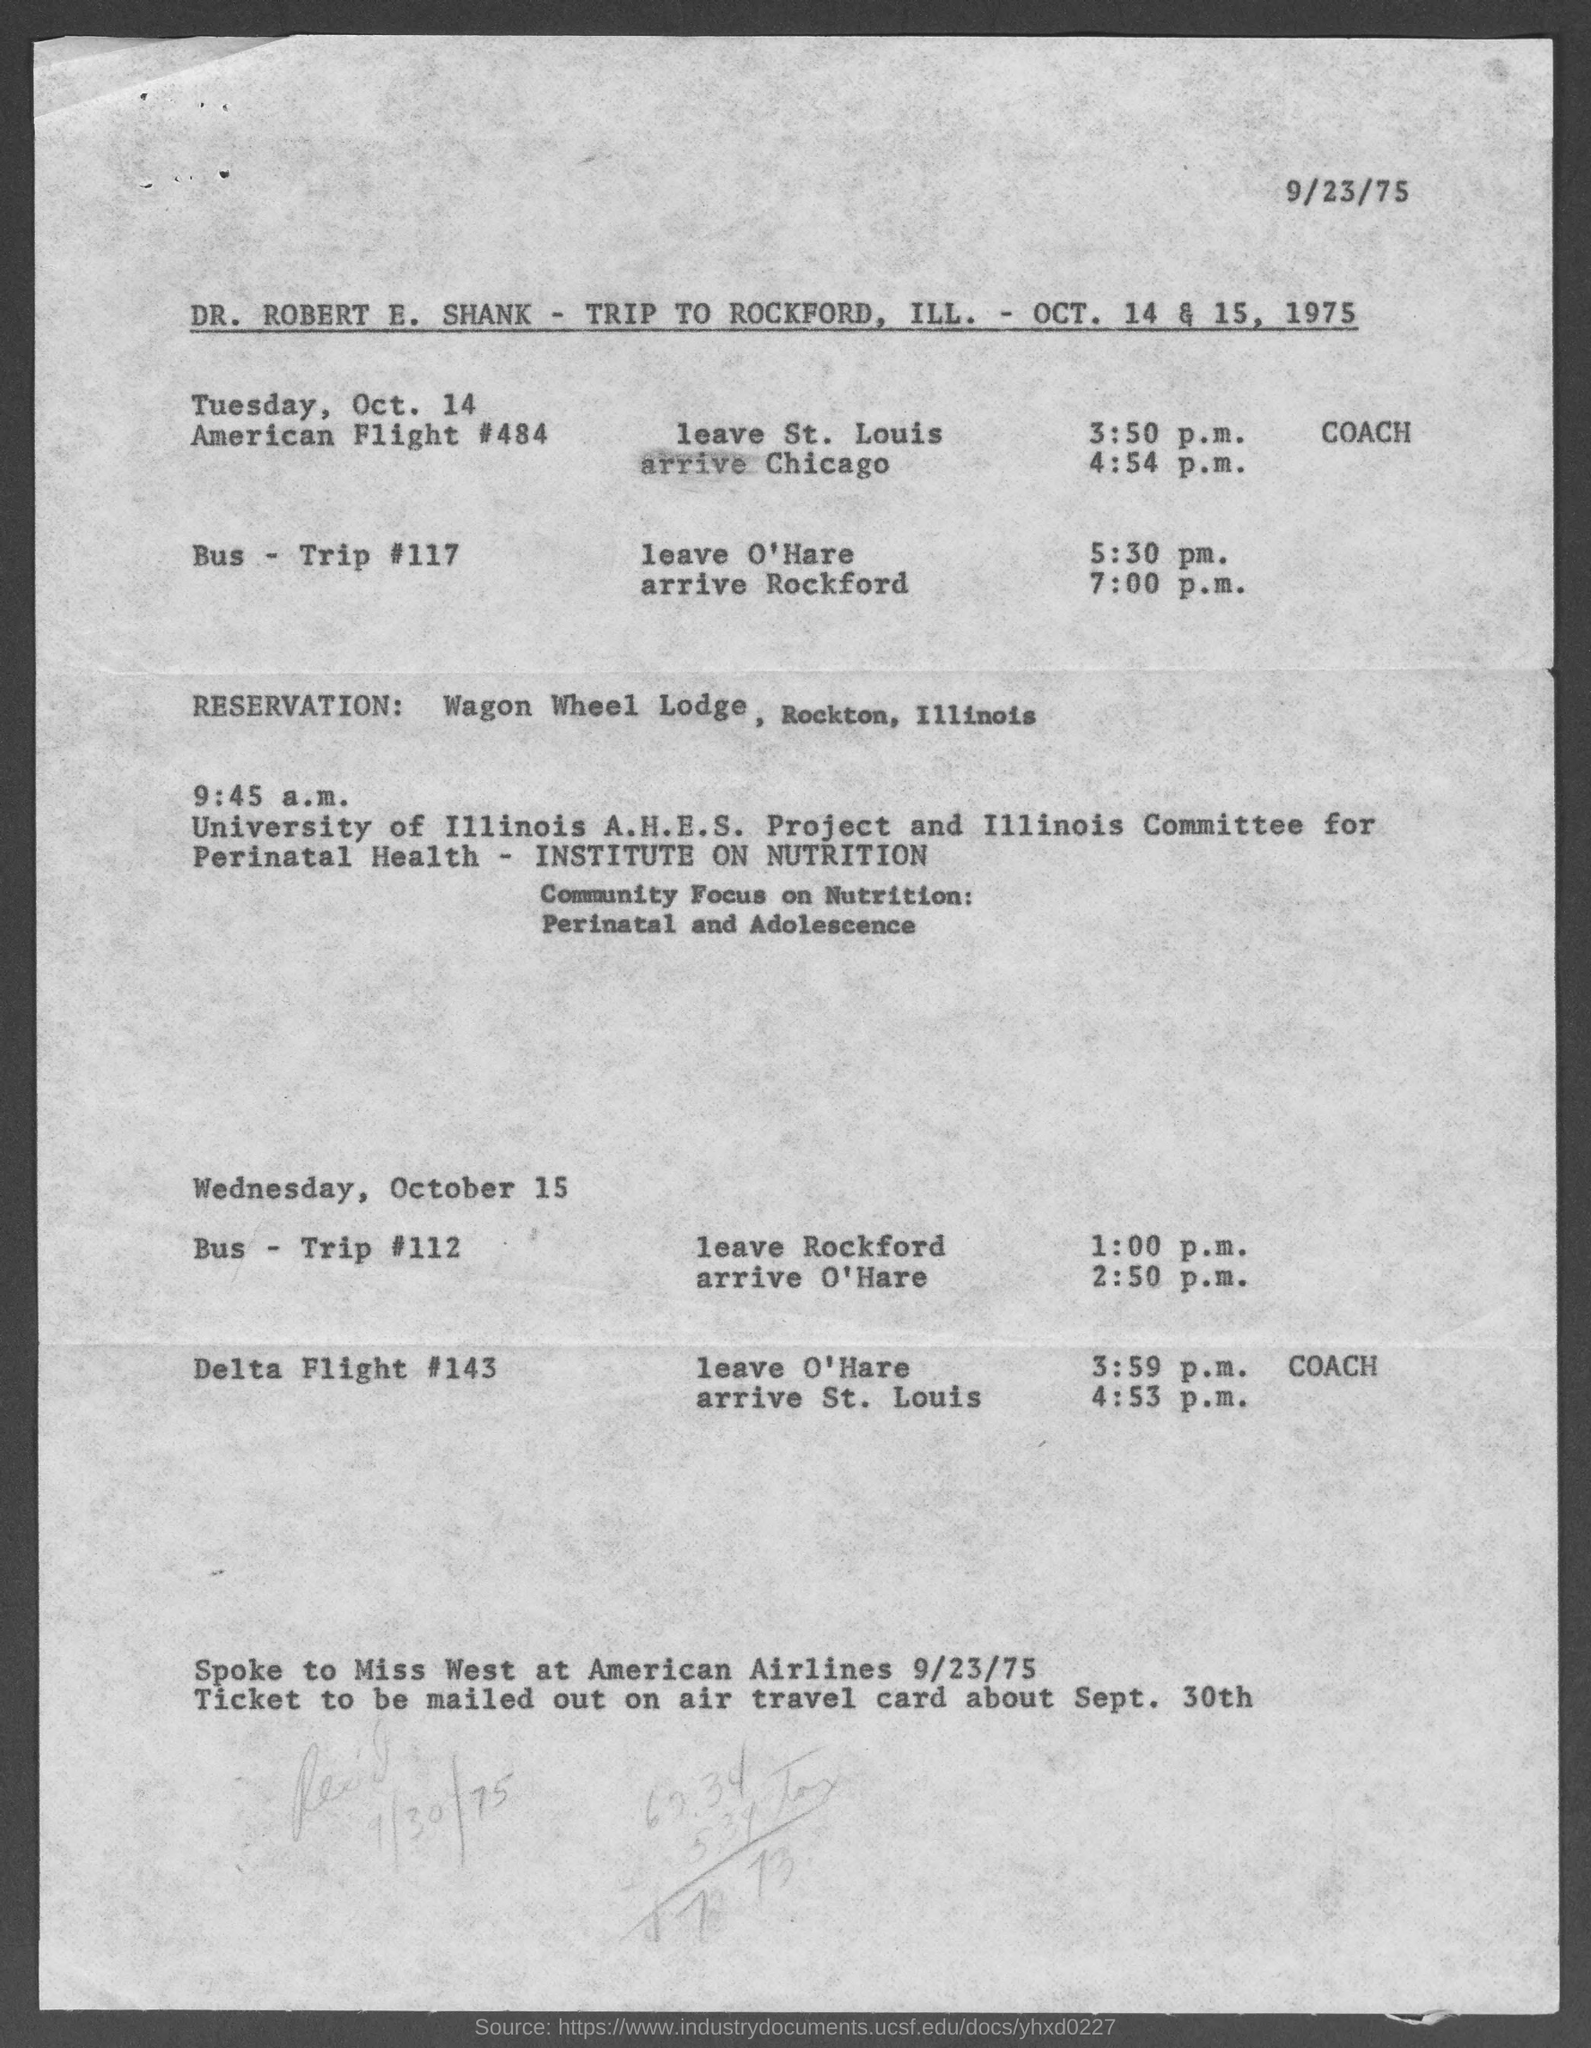What is the date at top-right of the page?
Your response must be concise. 9/23/75. Whose trip details are given in the page?
Your answer should be very brief. Dr. Robert E. Shank. Where is the reservation made at in rockford?
Your answer should be very brief. Wagon Wheel Lodge, Rockton, Illinois. 